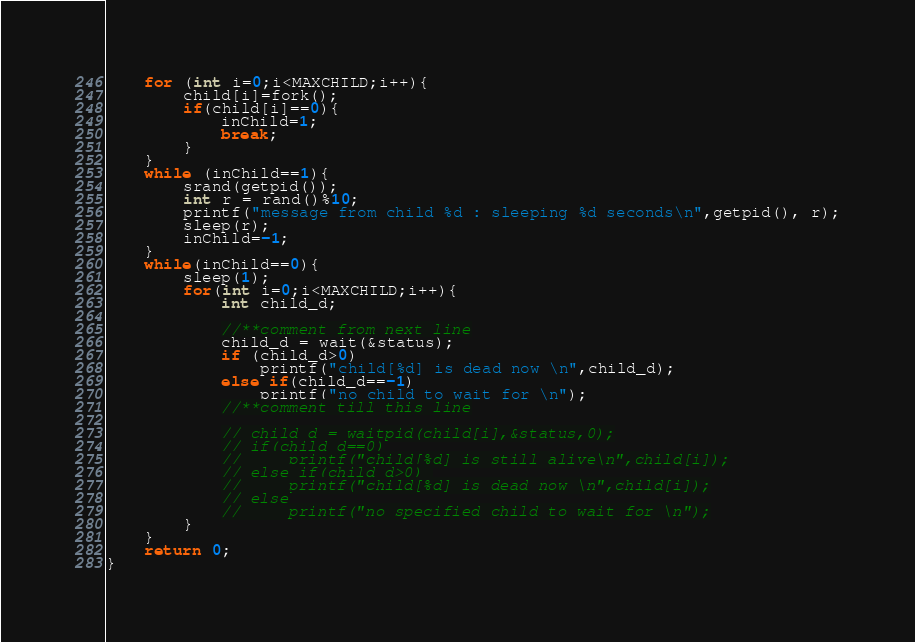<code> <loc_0><loc_0><loc_500><loc_500><_C_>    for (int i=0;i<MAXCHILD;i++){
        child[i]=fork();
        if(child[i]==0){
            inChild=1;
            break;
        }
    }
    while (inChild==1){
        srand(getpid());
        int r = rand()%10;
        printf("message from child %d : sleeping %d seconds\n",getpid(), r);
        sleep(r);
        inChild=-1;
    }
    while(inChild==0){
        sleep(1);
        for(int i=0;i<MAXCHILD;i++){
            int child_d;
            
            //**comment from next line
            child_d = wait(&status);
            if (child_d>0)
                printf("child[%d] is dead now \n",child_d);
            else if(child_d==-1)
                printf("no child to wait for \n");
            //**comment till this line

            // child_d = waitpid(child[i],&status,0);
            // if(child_d==0)
            //     printf("child[%d] is still alive\n",child[i]);
            // else if(child_d>0) 
            //     printf("child[%d] is dead now \n",child[i]);
            // else
            //     printf("no specified child to wait for \n");
        }
    }
    return 0;
}</code> 